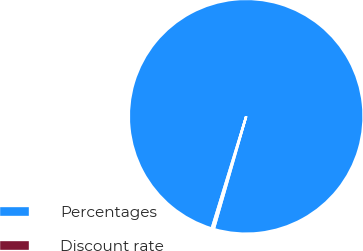Convert chart. <chart><loc_0><loc_0><loc_500><loc_500><pie_chart><fcel>Percentages<fcel>Discount rate<nl><fcel>99.71%<fcel>0.29%<nl></chart> 